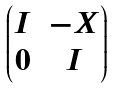Convert formula to latex. <formula><loc_0><loc_0><loc_500><loc_500>\begin{pmatrix} I & - X \\ 0 & I \\ \end{pmatrix}</formula> 